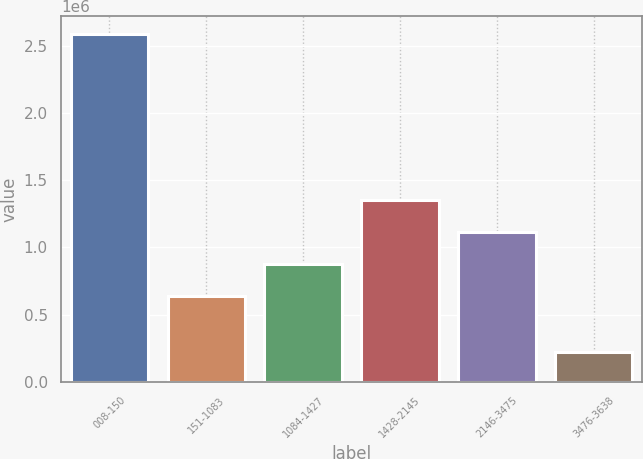Convert chart. <chart><loc_0><loc_0><loc_500><loc_500><bar_chart><fcel>008-150<fcel>151-1083<fcel>1084-1427<fcel>1428-2145<fcel>2146-3475<fcel>3476-3638<nl><fcel>2.59086e+06<fcel>639811<fcel>876391<fcel>1.34955e+06<fcel>1.11297e+06<fcel>225064<nl></chart> 